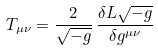<formula> <loc_0><loc_0><loc_500><loc_500>T _ { \mu \nu } = \frac { 2 } { \sqrt { - g } } \, \frac { \delta L \sqrt { - g } } { \delta g ^ { \mu \nu } }</formula> 